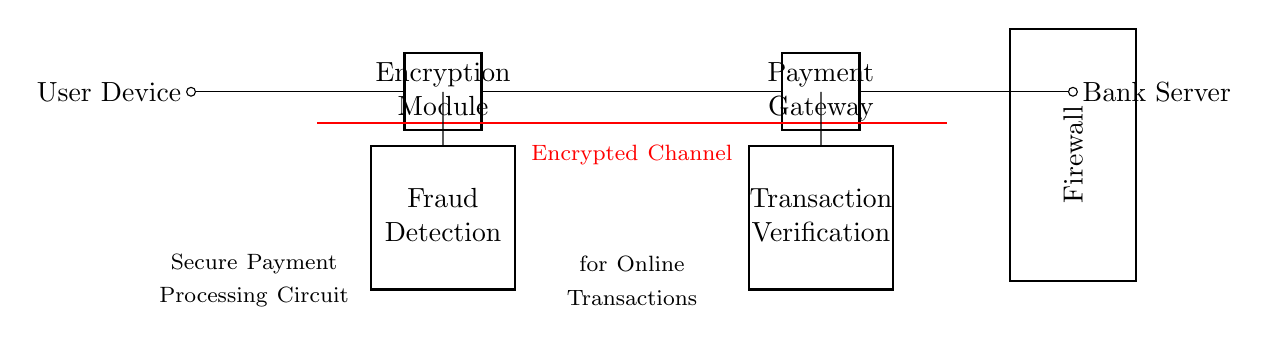What is the main component involved in encryption? The main component for encryption is the Encryption Module, which is the second component from the left in the circuit. It is labeled as such and is crucial for securing the transaction data before it is processed.
Answer: Encryption Module What type of connection is indicated in the circuit? The diagram shows an Encrypted Channel, indicated by a thick red line connecting the Encryption Module to the Payment Gateway. This shows that all data transferred through this connection is encrypted for security purposes.
Answer: Encrypted Channel How many ports are present in the Fraud Detection component? The Fraud Detection component is labeled as a four-port component, meaning it has four distinct connections available for data flow. This is specified in the labeling on the circuit diagram.
Answer: Four ports What does the Firewall protect? The Firewall acts as a security barrier protecting the Bank Server from unauthorized access, highlighted in the circuit diagram as a thick box surrounding its section. This is essential for preventing cyber threats during transactions.
Answer: Bank Server What process follows the Payment Gateway? The next process after the Payment Gateway is Transaction Verification, which is shown as a four-port component directly connected to the Payment Gateway. This implies a necessary authentication step before finalizing the transaction.
Answer: Transaction Verification 